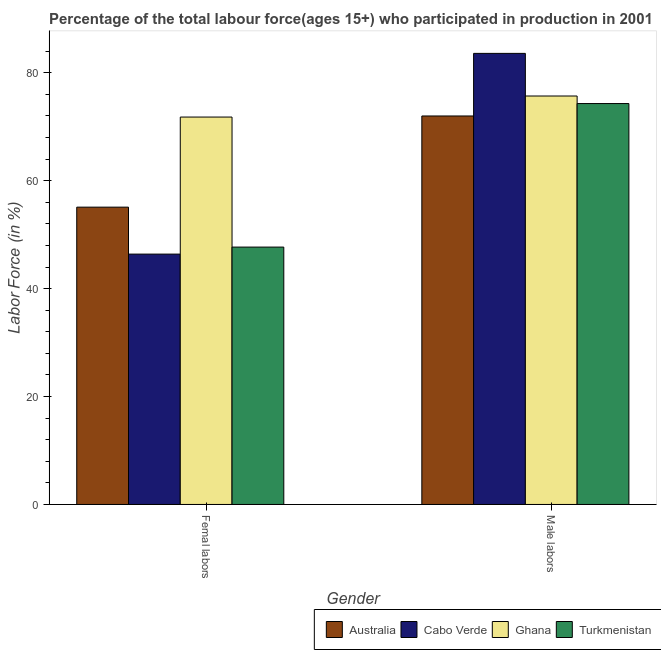How many different coloured bars are there?
Give a very brief answer. 4. Are the number of bars on each tick of the X-axis equal?
Keep it short and to the point. Yes. What is the label of the 1st group of bars from the left?
Your response must be concise. Femal labors. What is the percentage of female labor force in Ghana?
Keep it short and to the point. 71.8. Across all countries, what is the maximum percentage of male labour force?
Ensure brevity in your answer.  83.6. Across all countries, what is the minimum percentage of female labor force?
Your answer should be very brief. 46.4. What is the total percentage of female labor force in the graph?
Offer a terse response. 221. What is the difference between the percentage of female labor force in Australia and that in Ghana?
Give a very brief answer. -16.7. What is the difference between the percentage of female labor force in Ghana and the percentage of male labour force in Australia?
Offer a terse response. -0.2. What is the average percentage of female labor force per country?
Your response must be concise. 55.25. What is the difference between the percentage of male labour force and percentage of female labor force in Cabo Verde?
Offer a very short reply. 37.2. What is the ratio of the percentage of female labor force in Cabo Verde to that in Australia?
Provide a succinct answer. 0.84. Is the percentage of male labour force in Ghana less than that in Turkmenistan?
Give a very brief answer. No. What does the 4th bar from the left in Male labors represents?
Offer a very short reply. Turkmenistan. What does the 1st bar from the right in Femal labors represents?
Your answer should be very brief. Turkmenistan. How many bars are there?
Your response must be concise. 8. Are all the bars in the graph horizontal?
Your answer should be very brief. No. How many countries are there in the graph?
Your response must be concise. 4. What is the difference between two consecutive major ticks on the Y-axis?
Ensure brevity in your answer.  20. Are the values on the major ticks of Y-axis written in scientific E-notation?
Offer a very short reply. No. Does the graph contain grids?
Offer a terse response. No. Where does the legend appear in the graph?
Offer a very short reply. Bottom right. How many legend labels are there?
Your answer should be compact. 4. How are the legend labels stacked?
Provide a succinct answer. Horizontal. What is the title of the graph?
Your response must be concise. Percentage of the total labour force(ages 15+) who participated in production in 2001. What is the label or title of the Y-axis?
Your answer should be very brief. Labor Force (in %). What is the Labor Force (in %) of Australia in Femal labors?
Provide a succinct answer. 55.1. What is the Labor Force (in %) in Cabo Verde in Femal labors?
Offer a terse response. 46.4. What is the Labor Force (in %) in Ghana in Femal labors?
Your answer should be very brief. 71.8. What is the Labor Force (in %) of Turkmenistan in Femal labors?
Your answer should be compact. 47.7. What is the Labor Force (in %) of Australia in Male labors?
Provide a short and direct response. 72. What is the Labor Force (in %) of Cabo Verde in Male labors?
Ensure brevity in your answer.  83.6. What is the Labor Force (in %) in Ghana in Male labors?
Your answer should be very brief. 75.7. What is the Labor Force (in %) of Turkmenistan in Male labors?
Provide a short and direct response. 74.3. Across all Gender, what is the maximum Labor Force (in %) of Cabo Verde?
Your answer should be very brief. 83.6. Across all Gender, what is the maximum Labor Force (in %) in Ghana?
Provide a succinct answer. 75.7. Across all Gender, what is the maximum Labor Force (in %) of Turkmenistan?
Your answer should be very brief. 74.3. Across all Gender, what is the minimum Labor Force (in %) in Australia?
Your answer should be very brief. 55.1. Across all Gender, what is the minimum Labor Force (in %) of Cabo Verde?
Make the answer very short. 46.4. Across all Gender, what is the minimum Labor Force (in %) of Ghana?
Make the answer very short. 71.8. Across all Gender, what is the minimum Labor Force (in %) in Turkmenistan?
Provide a short and direct response. 47.7. What is the total Labor Force (in %) in Australia in the graph?
Ensure brevity in your answer.  127.1. What is the total Labor Force (in %) of Cabo Verde in the graph?
Offer a terse response. 130. What is the total Labor Force (in %) of Ghana in the graph?
Your response must be concise. 147.5. What is the total Labor Force (in %) in Turkmenistan in the graph?
Give a very brief answer. 122. What is the difference between the Labor Force (in %) of Australia in Femal labors and that in Male labors?
Give a very brief answer. -16.9. What is the difference between the Labor Force (in %) in Cabo Verde in Femal labors and that in Male labors?
Your response must be concise. -37.2. What is the difference between the Labor Force (in %) of Turkmenistan in Femal labors and that in Male labors?
Ensure brevity in your answer.  -26.6. What is the difference between the Labor Force (in %) of Australia in Femal labors and the Labor Force (in %) of Cabo Verde in Male labors?
Give a very brief answer. -28.5. What is the difference between the Labor Force (in %) of Australia in Femal labors and the Labor Force (in %) of Ghana in Male labors?
Provide a short and direct response. -20.6. What is the difference between the Labor Force (in %) of Australia in Femal labors and the Labor Force (in %) of Turkmenistan in Male labors?
Offer a terse response. -19.2. What is the difference between the Labor Force (in %) in Cabo Verde in Femal labors and the Labor Force (in %) in Ghana in Male labors?
Your answer should be very brief. -29.3. What is the difference between the Labor Force (in %) in Cabo Verde in Femal labors and the Labor Force (in %) in Turkmenistan in Male labors?
Offer a very short reply. -27.9. What is the difference between the Labor Force (in %) in Ghana in Femal labors and the Labor Force (in %) in Turkmenistan in Male labors?
Offer a very short reply. -2.5. What is the average Labor Force (in %) of Australia per Gender?
Your response must be concise. 63.55. What is the average Labor Force (in %) of Cabo Verde per Gender?
Ensure brevity in your answer.  65. What is the average Labor Force (in %) of Ghana per Gender?
Ensure brevity in your answer.  73.75. What is the difference between the Labor Force (in %) in Australia and Labor Force (in %) in Ghana in Femal labors?
Make the answer very short. -16.7. What is the difference between the Labor Force (in %) of Australia and Labor Force (in %) of Turkmenistan in Femal labors?
Your answer should be compact. 7.4. What is the difference between the Labor Force (in %) of Cabo Verde and Labor Force (in %) of Ghana in Femal labors?
Your answer should be compact. -25.4. What is the difference between the Labor Force (in %) of Ghana and Labor Force (in %) of Turkmenistan in Femal labors?
Give a very brief answer. 24.1. What is the difference between the Labor Force (in %) of Australia and Labor Force (in %) of Ghana in Male labors?
Give a very brief answer. -3.7. What is the ratio of the Labor Force (in %) of Australia in Femal labors to that in Male labors?
Your answer should be very brief. 0.77. What is the ratio of the Labor Force (in %) of Cabo Verde in Femal labors to that in Male labors?
Your response must be concise. 0.56. What is the ratio of the Labor Force (in %) in Ghana in Femal labors to that in Male labors?
Your answer should be very brief. 0.95. What is the ratio of the Labor Force (in %) in Turkmenistan in Femal labors to that in Male labors?
Your answer should be very brief. 0.64. What is the difference between the highest and the second highest Labor Force (in %) in Cabo Verde?
Provide a short and direct response. 37.2. What is the difference between the highest and the second highest Labor Force (in %) in Ghana?
Make the answer very short. 3.9. What is the difference between the highest and the second highest Labor Force (in %) in Turkmenistan?
Offer a terse response. 26.6. What is the difference between the highest and the lowest Labor Force (in %) in Cabo Verde?
Provide a short and direct response. 37.2. What is the difference between the highest and the lowest Labor Force (in %) of Turkmenistan?
Your answer should be compact. 26.6. 